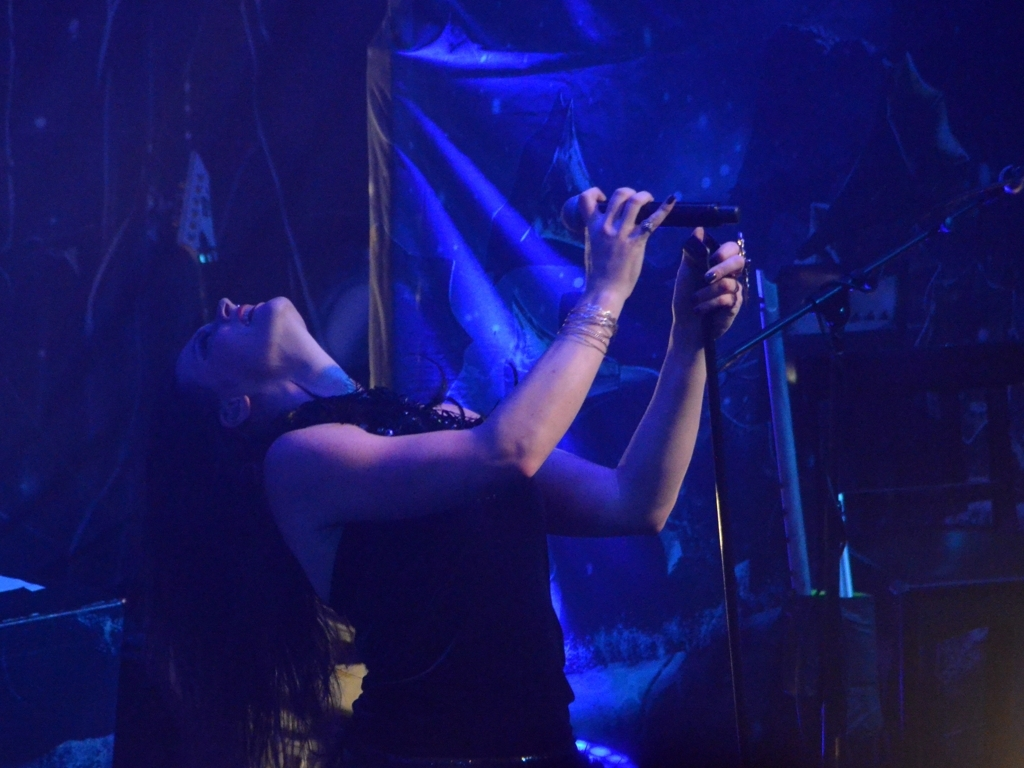Are the colors in the image vibrant? The image shows moderate vibrancy with a focus on deep blues and contrasting stage lighting, which offers a sense of dynamism but may not be considered highly vibrant due to the predominance of darker tones. 